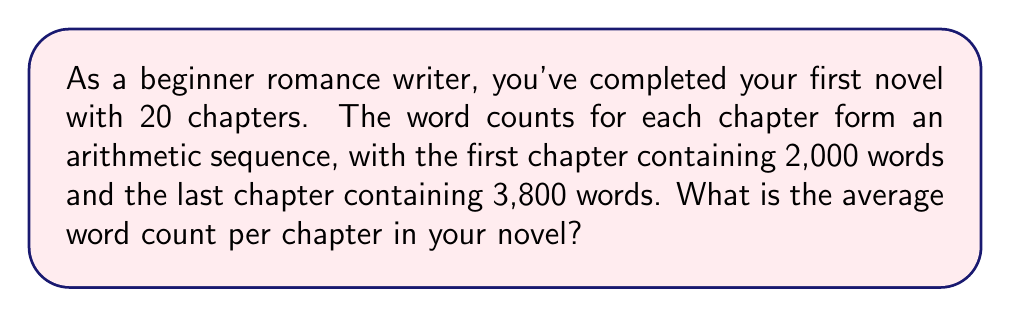What is the answer to this math problem? Let's approach this step-by-step:

1) In an arithmetic sequence, the difference between each term is constant. Let's call this common difference $d$.

2) We can find $d$ using the first and last terms:
   $d = \frac{3800 - 2000}{19} = 94.74$

3) The arithmetic sequence formula is:
   $a_n = a_1 + (n-1)d$
   where $a_n$ is the nth term, $a_1$ is the first term, and $n$ is the number of terms.

4) The sum of an arithmetic sequence is given by:
   $S_n = \frac{n}{2}(a_1 + a_n)$
   where $S_n$ is the sum of $n$ terms.

5) In this case:
   $n = 20$ (number of chapters)
   $a_1 = 2000$ (first chapter word count)
   $a_n = a_{20} = 3800$ (last chapter word count)

6) Plugging these into the sum formula:
   $S_{20} = \frac{20}{2}(2000 + 3800) = 10 \times 5800 = 58000$

7) The average word count is the total words divided by the number of chapters:
   $\text{Average} = \frac{58000}{20} = 2900$

Therefore, the average word count per chapter is 2,900 words.
Answer: 2,900 words 